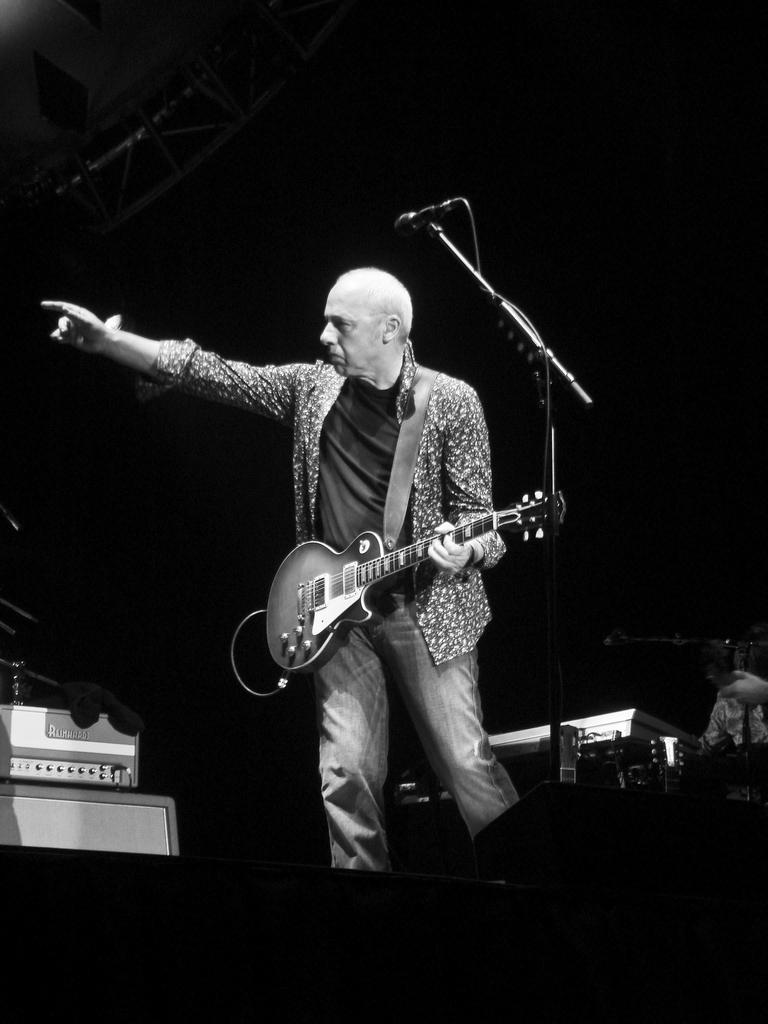What is the main subject of the image? There is a person in the image. What is the person doing in the image? The person is standing in front of a mic and holding a guitar. What type of string can be seen hanging from the mic in the image? There is no string hanging from the mic in the image. Is there a squirrel visible in the image? No, there is no squirrel present in the image. 